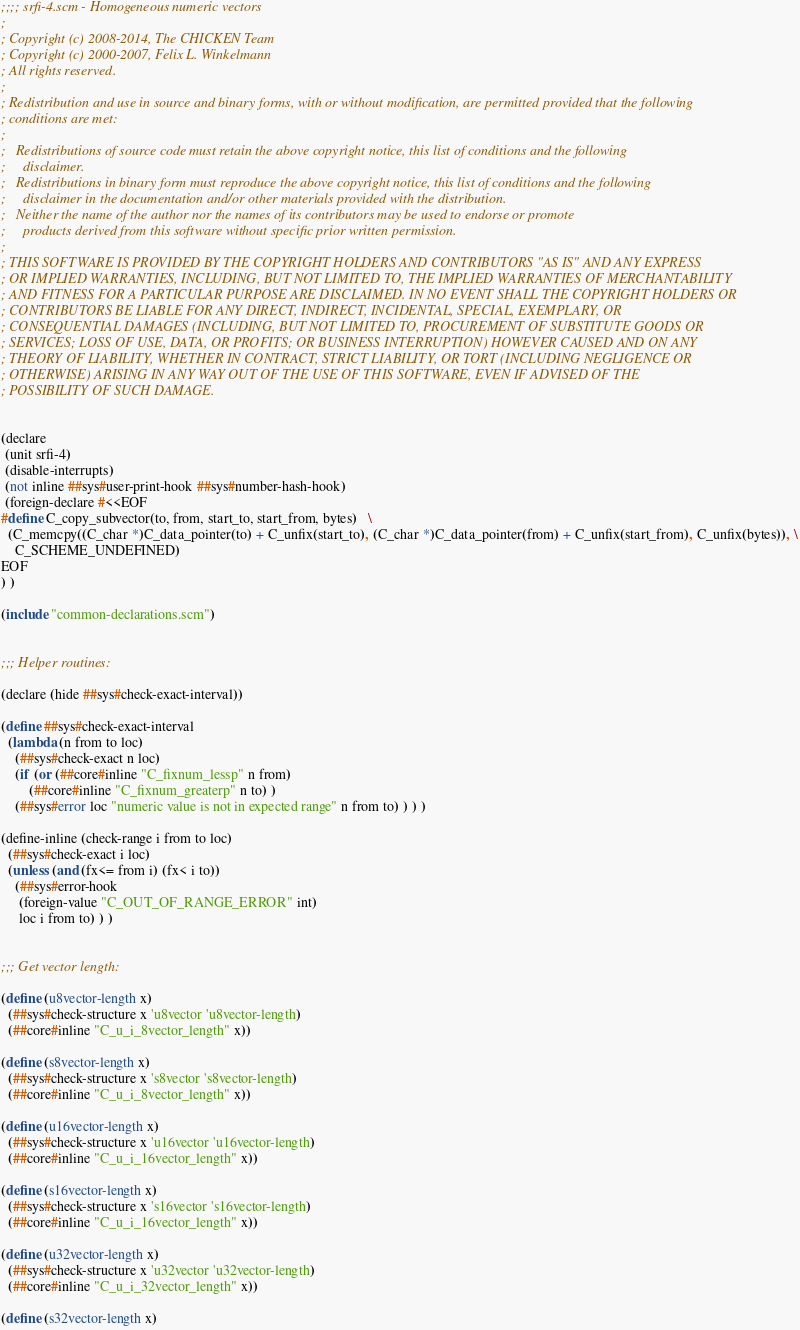Convert code to text. <code><loc_0><loc_0><loc_500><loc_500><_Scheme_>;;;; srfi-4.scm - Homogeneous numeric vectors
;
; Copyright (c) 2008-2014, The CHICKEN Team
; Copyright (c) 2000-2007, Felix L. Winkelmann
; All rights reserved.
;
; Redistribution and use in source and binary forms, with or without modification, are permitted provided that the following
; conditions are met:
;
;   Redistributions of source code must retain the above copyright notice, this list of conditions and the following
;     disclaimer.
;   Redistributions in binary form must reproduce the above copyright notice, this list of conditions and the following
;     disclaimer in the documentation and/or other materials provided with the distribution.
;   Neither the name of the author nor the names of its contributors may be used to endorse or promote
;     products derived from this software without specific prior written permission.
;
; THIS SOFTWARE IS PROVIDED BY THE COPYRIGHT HOLDERS AND CONTRIBUTORS "AS IS" AND ANY EXPRESS
; OR IMPLIED WARRANTIES, INCLUDING, BUT NOT LIMITED TO, THE IMPLIED WARRANTIES OF MERCHANTABILITY
; AND FITNESS FOR A PARTICULAR PURPOSE ARE DISCLAIMED. IN NO EVENT SHALL THE COPYRIGHT HOLDERS OR
; CONTRIBUTORS BE LIABLE FOR ANY DIRECT, INDIRECT, INCIDENTAL, SPECIAL, EXEMPLARY, OR
; CONSEQUENTIAL DAMAGES (INCLUDING, BUT NOT LIMITED TO, PROCUREMENT OF SUBSTITUTE GOODS OR
; SERVICES; LOSS OF USE, DATA, OR PROFITS; OR BUSINESS INTERRUPTION) HOWEVER CAUSED AND ON ANY
; THEORY OF LIABILITY, WHETHER IN CONTRACT, STRICT LIABILITY, OR TORT (INCLUDING NEGLIGENCE OR
; OTHERWISE) ARISING IN ANY WAY OUT OF THE USE OF THIS SOFTWARE, EVEN IF ADVISED OF THE
; POSSIBILITY OF SUCH DAMAGE.


(declare
 (unit srfi-4)
 (disable-interrupts)
 (not inline ##sys#user-print-hook ##sys#number-hash-hook)
 (foreign-declare #<<EOF
#define C_copy_subvector(to, from, start_to, start_from, bytes)   \
  (C_memcpy((C_char *)C_data_pointer(to) + C_unfix(start_to), (C_char *)C_data_pointer(from) + C_unfix(start_from), C_unfix(bytes)), \
    C_SCHEME_UNDEFINED)
EOF
) )

(include "common-declarations.scm")


;;; Helper routines:

(declare (hide ##sys#check-exact-interval))

(define ##sys#check-exact-interval
  (lambda (n from to loc)
    (##sys#check-exact n loc)
    (if (or (##core#inline "C_fixnum_lessp" n from)
	    (##core#inline "C_fixnum_greaterp" n to) )
	(##sys#error loc "numeric value is not in expected range" n from to) ) ) )

(define-inline (check-range i from to loc)
  (##sys#check-exact i loc)
  (unless (and (fx<= from i) (fx< i to))
    (##sys#error-hook
     (foreign-value "C_OUT_OF_RANGE_ERROR" int)
     loc i from to) ) )


;;; Get vector length:

(define (u8vector-length x)
  (##sys#check-structure x 'u8vector 'u8vector-length)
  (##core#inline "C_u_i_8vector_length" x))

(define (s8vector-length x)
  (##sys#check-structure x 's8vector 's8vector-length)
  (##core#inline "C_u_i_8vector_length" x))

(define (u16vector-length x)
  (##sys#check-structure x 'u16vector 'u16vector-length)
  (##core#inline "C_u_i_16vector_length" x))

(define (s16vector-length x)
  (##sys#check-structure x 's16vector 's16vector-length)
  (##core#inline "C_u_i_16vector_length" x))

(define (u32vector-length x)
  (##sys#check-structure x 'u32vector 'u32vector-length)
  (##core#inline "C_u_i_32vector_length" x))

(define (s32vector-length x)</code> 